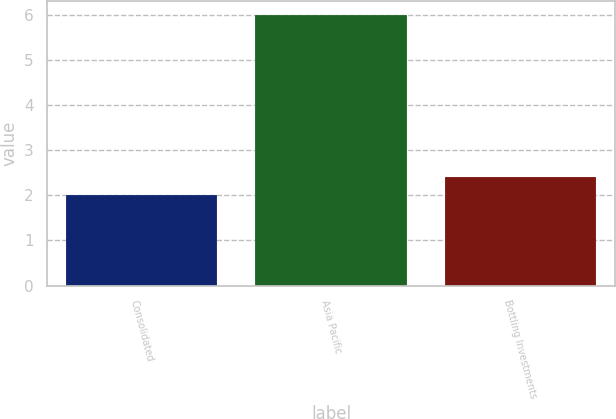Convert chart. <chart><loc_0><loc_0><loc_500><loc_500><bar_chart><fcel>Consolidated<fcel>Asia Pacific<fcel>Bottling Investments<nl><fcel>2<fcel>6<fcel>2.4<nl></chart> 